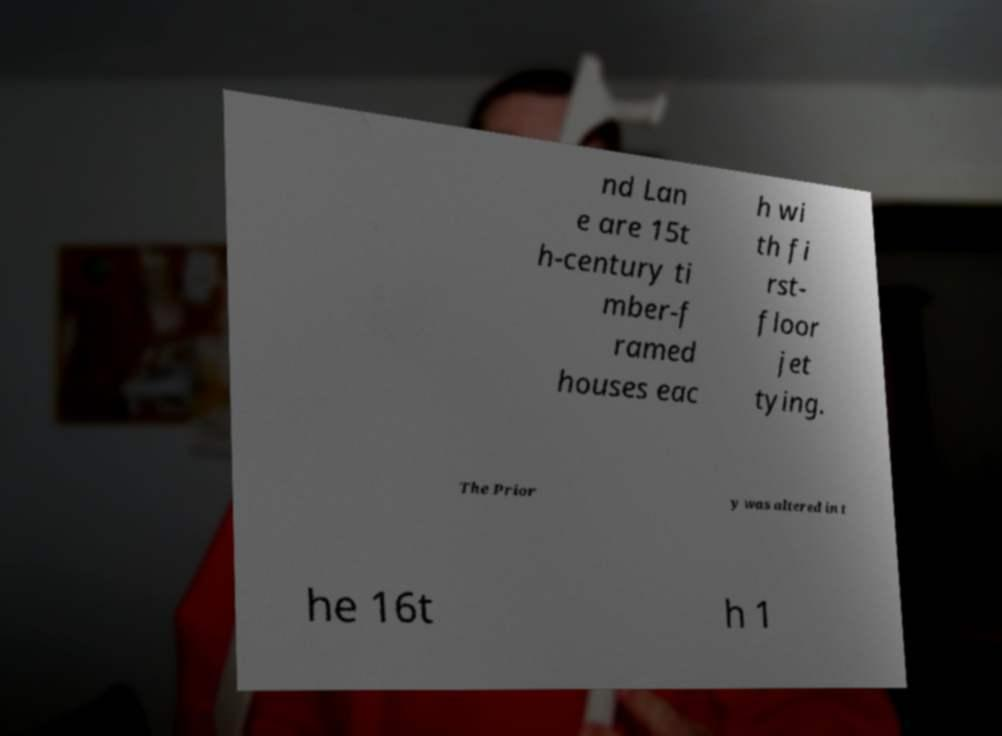There's text embedded in this image that I need extracted. Can you transcribe it verbatim? nd Lan e are 15t h-century ti mber-f ramed houses eac h wi th fi rst- floor jet tying. The Prior y was altered in t he 16t h 1 